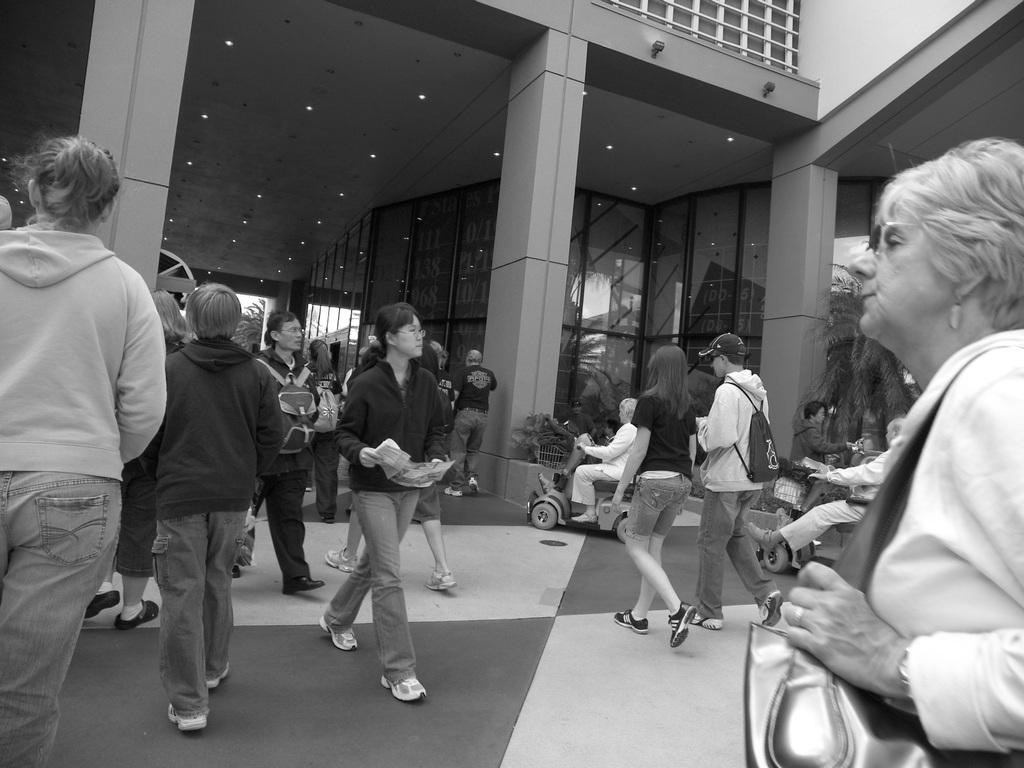What are the people in the image doing? The people in the image are walking. What type of building can be seen in the image? There is a building with glass in the image. What natural elements are visible in the image? There are trees visible in the image. How many cows can be seen grazing in the image? There are no cows present in the image. What type of fold is used to store the key in the image? There is no key or fold present in the image. 